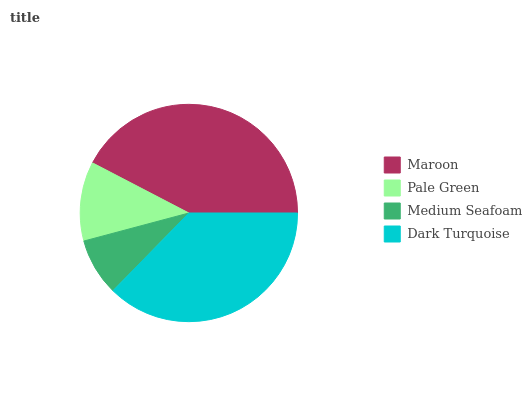Is Medium Seafoam the minimum?
Answer yes or no. Yes. Is Maroon the maximum?
Answer yes or no. Yes. Is Pale Green the minimum?
Answer yes or no. No. Is Pale Green the maximum?
Answer yes or no. No. Is Maroon greater than Pale Green?
Answer yes or no. Yes. Is Pale Green less than Maroon?
Answer yes or no. Yes. Is Pale Green greater than Maroon?
Answer yes or no. No. Is Maroon less than Pale Green?
Answer yes or no. No. Is Dark Turquoise the high median?
Answer yes or no. Yes. Is Pale Green the low median?
Answer yes or no. Yes. Is Pale Green the high median?
Answer yes or no. No. Is Dark Turquoise the low median?
Answer yes or no. No. 